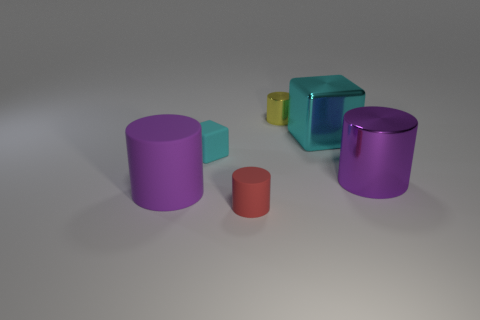There is a rubber thing that is in front of the large purple cylinder in front of the large purple metallic object; what shape is it?
Your answer should be very brief. Cylinder. There is a shiny object that is the same color as the large rubber thing; what size is it?
Provide a succinct answer. Large. Are there any red cubes made of the same material as the small red cylinder?
Offer a very short reply. No. There is a big object that is in front of the big metal cylinder; what is its material?
Make the answer very short. Rubber. What is the big cyan cube made of?
Provide a short and direct response. Metal. Are the purple object on the right side of the big purple rubber thing and the tiny cube made of the same material?
Your answer should be compact. No. Are there fewer tiny rubber blocks on the right side of the tiny cyan matte block than cyan shiny cylinders?
Give a very brief answer. No. What is the color of the shiny cylinder that is the same size as the cyan rubber cube?
Your response must be concise. Yellow. How many cyan metal things are the same shape as the tiny cyan matte thing?
Provide a short and direct response. 1. What is the color of the large cube that is in front of the yellow cylinder?
Provide a short and direct response. Cyan. 